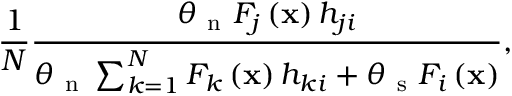<formula> <loc_0><loc_0><loc_500><loc_500>\frac { 1 } { N } \frac { \theta _ { n } F _ { j } \left ( x \right ) h _ { j i } } { \theta _ { n } \sum _ { k = 1 } ^ { N } F _ { k } \left ( x \right ) h _ { k i } + \theta _ { s } F _ { i } \left ( x \right ) } ,</formula> 